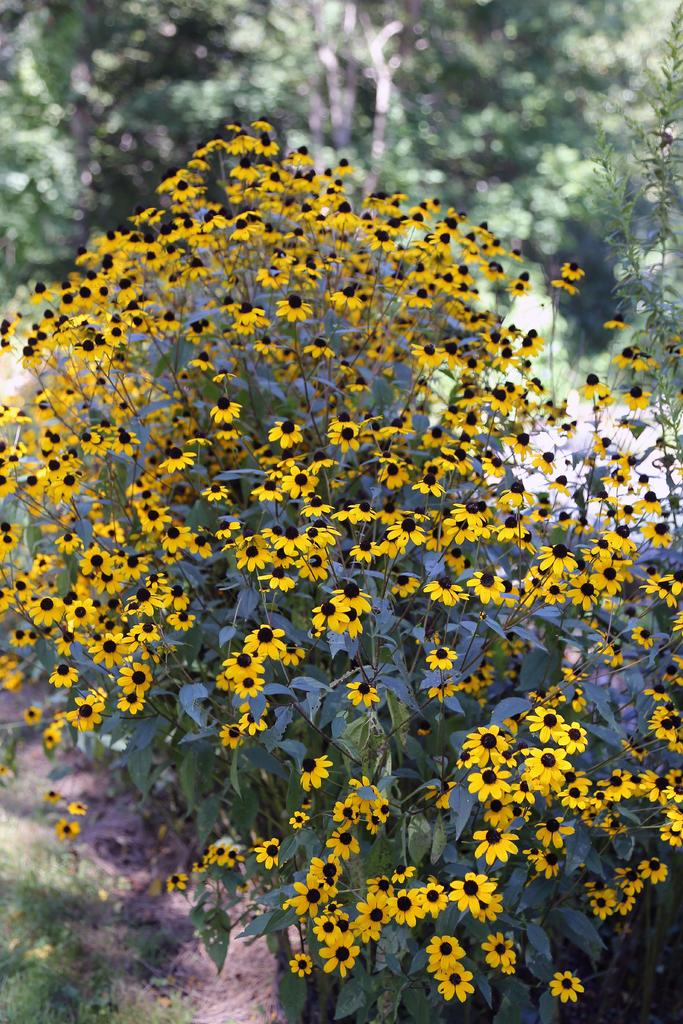What type of plants can be seen in the image? There are plants with flowers in the image. What can be seen in the background of the image? There are trees in the background of the image. What is covering the ground in the image? There is grass on the ground in the image. What type of linen can be seen draped over the plants in the image? There is no linen present in the image; the plants are not covered by any fabric. 